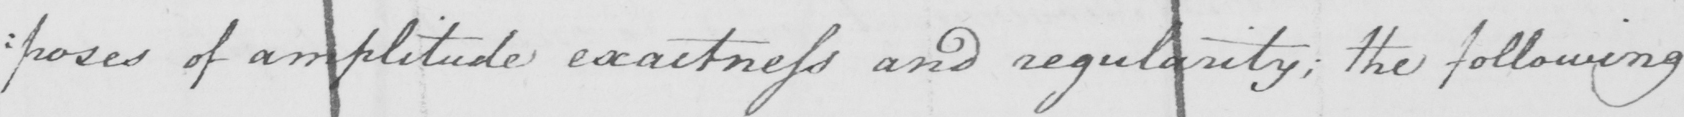What does this handwritten line say? : poses of amplitude exactness and regularity ; the following 